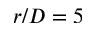Convert formula to latex. <formula><loc_0><loc_0><loc_500><loc_500>r / D = 5</formula> 